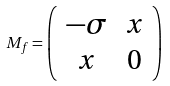Convert formula to latex. <formula><loc_0><loc_0><loc_500><loc_500>M _ { f } = \left ( \begin{array} { c c } - \sigma & x \\ x & 0 \end{array} \right )</formula> 